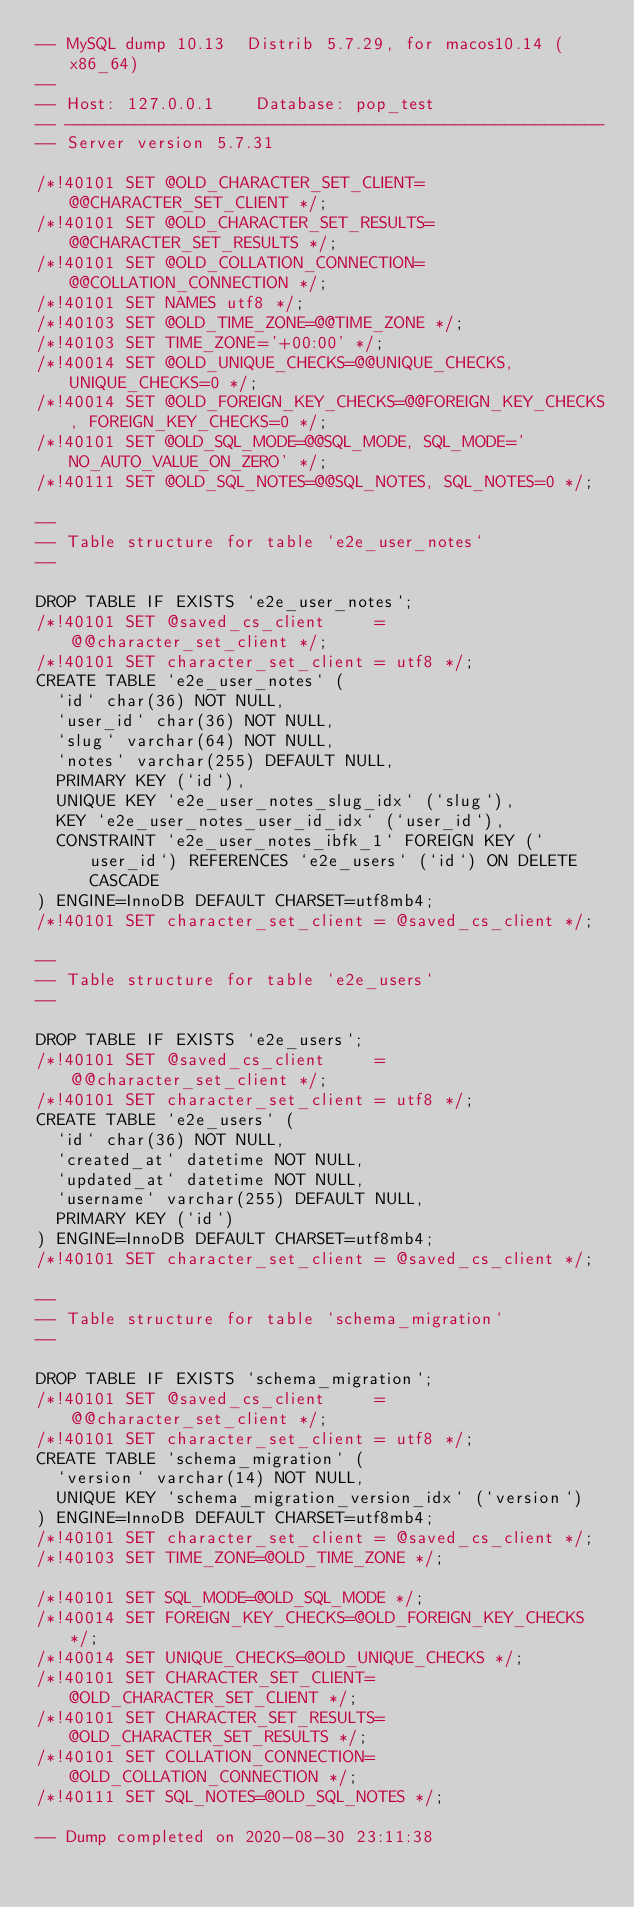Convert code to text. <code><loc_0><loc_0><loc_500><loc_500><_SQL_>-- MySQL dump 10.13  Distrib 5.7.29, for macos10.14 (x86_64)
--
-- Host: 127.0.0.1    Database: pop_test
-- ------------------------------------------------------
-- Server version	5.7.31

/*!40101 SET @OLD_CHARACTER_SET_CLIENT=@@CHARACTER_SET_CLIENT */;
/*!40101 SET @OLD_CHARACTER_SET_RESULTS=@@CHARACTER_SET_RESULTS */;
/*!40101 SET @OLD_COLLATION_CONNECTION=@@COLLATION_CONNECTION */;
/*!40101 SET NAMES utf8 */;
/*!40103 SET @OLD_TIME_ZONE=@@TIME_ZONE */;
/*!40103 SET TIME_ZONE='+00:00' */;
/*!40014 SET @OLD_UNIQUE_CHECKS=@@UNIQUE_CHECKS, UNIQUE_CHECKS=0 */;
/*!40014 SET @OLD_FOREIGN_KEY_CHECKS=@@FOREIGN_KEY_CHECKS, FOREIGN_KEY_CHECKS=0 */;
/*!40101 SET @OLD_SQL_MODE=@@SQL_MODE, SQL_MODE='NO_AUTO_VALUE_ON_ZERO' */;
/*!40111 SET @OLD_SQL_NOTES=@@SQL_NOTES, SQL_NOTES=0 */;

--
-- Table structure for table `e2e_user_notes`
--

DROP TABLE IF EXISTS `e2e_user_notes`;
/*!40101 SET @saved_cs_client     = @@character_set_client */;
/*!40101 SET character_set_client = utf8 */;
CREATE TABLE `e2e_user_notes` (
  `id` char(36) NOT NULL,
  `user_id` char(36) NOT NULL,
  `slug` varchar(64) NOT NULL,
  `notes` varchar(255) DEFAULT NULL,
  PRIMARY KEY (`id`),
  UNIQUE KEY `e2e_user_notes_slug_idx` (`slug`),
  KEY `e2e_user_notes_user_id_idx` (`user_id`),
  CONSTRAINT `e2e_user_notes_ibfk_1` FOREIGN KEY (`user_id`) REFERENCES `e2e_users` (`id`) ON DELETE CASCADE
) ENGINE=InnoDB DEFAULT CHARSET=utf8mb4;
/*!40101 SET character_set_client = @saved_cs_client */;

--
-- Table structure for table `e2e_users`
--

DROP TABLE IF EXISTS `e2e_users`;
/*!40101 SET @saved_cs_client     = @@character_set_client */;
/*!40101 SET character_set_client = utf8 */;
CREATE TABLE `e2e_users` (
  `id` char(36) NOT NULL,
  `created_at` datetime NOT NULL,
  `updated_at` datetime NOT NULL,
  `username` varchar(255) DEFAULT NULL,
  PRIMARY KEY (`id`)
) ENGINE=InnoDB DEFAULT CHARSET=utf8mb4;
/*!40101 SET character_set_client = @saved_cs_client */;

--
-- Table structure for table `schema_migration`
--

DROP TABLE IF EXISTS `schema_migration`;
/*!40101 SET @saved_cs_client     = @@character_set_client */;
/*!40101 SET character_set_client = utf8 */;
CREATE TABLE `schema_migration` (
  `version` varchar(14) NOT NULL,
  UNIQUE KEY `schema_migration_version_idx` (`version`)
) ENGINE=InnoDB DEFAULT CHARSET=utf8mb4;
/*!40101 SET character_set_client = @saved_cs_client */;
/*!40103 SET TIME_ZONE=@OLD_TIME_ZONE */;

/*!40101 SET SQL_MODE=@OLD_SQL_MODE */;
/*!40014 SET FOREIGN_KEY_CHECKS=@OLD_FOREIGN_KEY_CHECKS */;
/*!40014 SET UNIQUE_CHECKS=@OLD_UNIQUE_CHECKS */;
/*!40101 SET CHARACTER_SET_CLIENT=@OLD_CHARACTER_SET_CLIENT */;
/*!40101 SET CHARACTER_SET_RESULTS=@OLD_CHARACTER_SET_RESULTS */;
/*!40101 SET COLLATION_CONNECTION=@OLD_COLLATION_CONNECTION */;
/*!40111 SET SQL_NOTES=@OLD_SQL_NOTES */;

-- Dump completed on 2020-08-30 23:11:38
</code> 